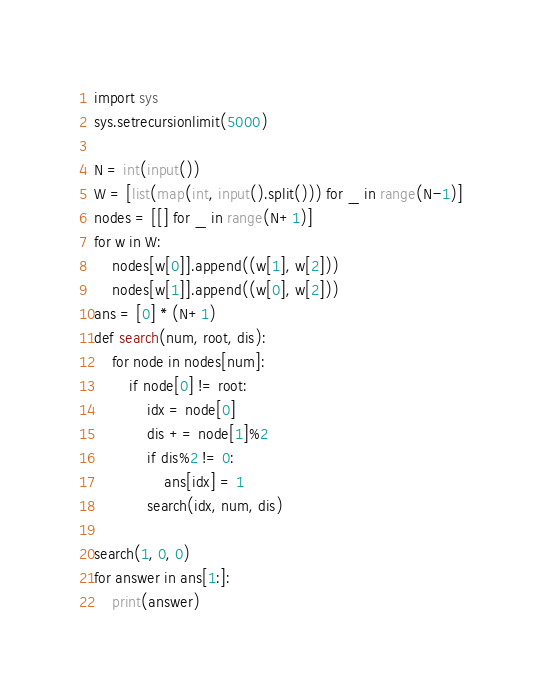<code> <loc_0><loc_0><loc_500><loc_500><_Python_>import sys
sys.setrecursionlimit(5000)

N = int(input())
W = [list(map(int, input().split())) for _ in range(N-1)]
nodes = [[] for _ in range(N+1)]
for w in W:
    nodes[w[0]].append((w[1], w[2]))
    nodes[w[1]].append((w[0], w[2]))
ans = [0] * (N+1)
def search(num, root, dis):
    for node in nodes[num]:
        if node[0] != root:
            idx = node[0]
            dis += node[1]%2
            if dis%2 != 0:
                ans[idx] = 1
            search(idx, num, dis)

search(1, 0, 0)
for answer in ans[1:]:
    print(answer)

</code> 